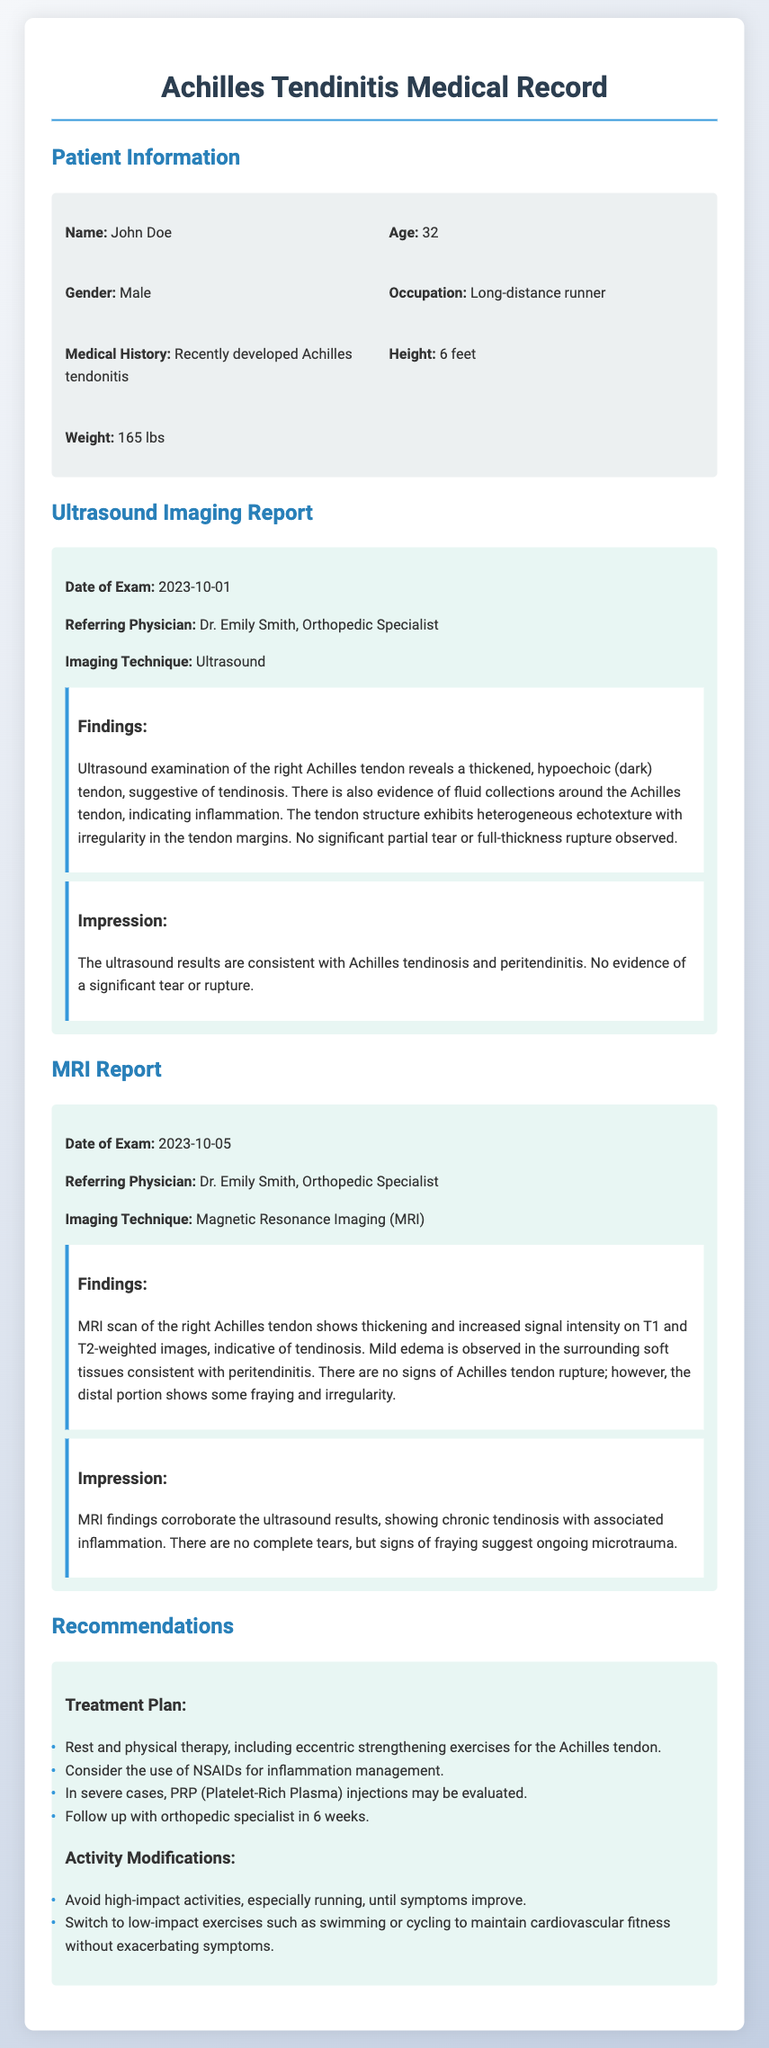what is the name of the patient? The name of the patient is mentioned in the patient information section of the document.
Answer: John Doe what is the age of the patient? The document states the patient's age in the patient information section.
Answer: 32 who is the referring physician for the ultrasound? The referring physician for the ultrasound is listed in the ultrasound imaging report.
Answer: Dr. Emily Smith what findings were reported on the ultrasound? The findings section of the ultrasound report describes the conditions observed in the Achilles tendon.
Answer: Thickened, hypoechoic tendon suggestive of tendinosis what date was the MRI exam conducted? The date of the MRI exam is specified in the MRI report section of the document.
Answer: 2023-10-05 what is the indication of the fraying in the MRI findings? The impression of the MRI report indicates the significance of the fraying observed in the tendon.
Answer: Ongoing microtrauma what is the first recommendation for treatment? The treatment plan in the recommendations section outlines various treatment options, starting with the first one.
Answer: Rest and physical therapy which imaging technique was used for the second exam? The imaging technique for the MRI exam is listed in the MRI report section.
Answer: Magnetic Resonance Imaging (MRI) what activity modification is suggested regarding running? The activity modifications section addresses recommendations for high-impact activities like running.
Answer: Avoid high-impact activities, especially running what evidence of inflammation was mentioned in the ultrasound report? The ultrasound findings specifically mention any fluid collections around the tendon associated with inflammation.
Answer: Fluid collections around the Achilles tendon 